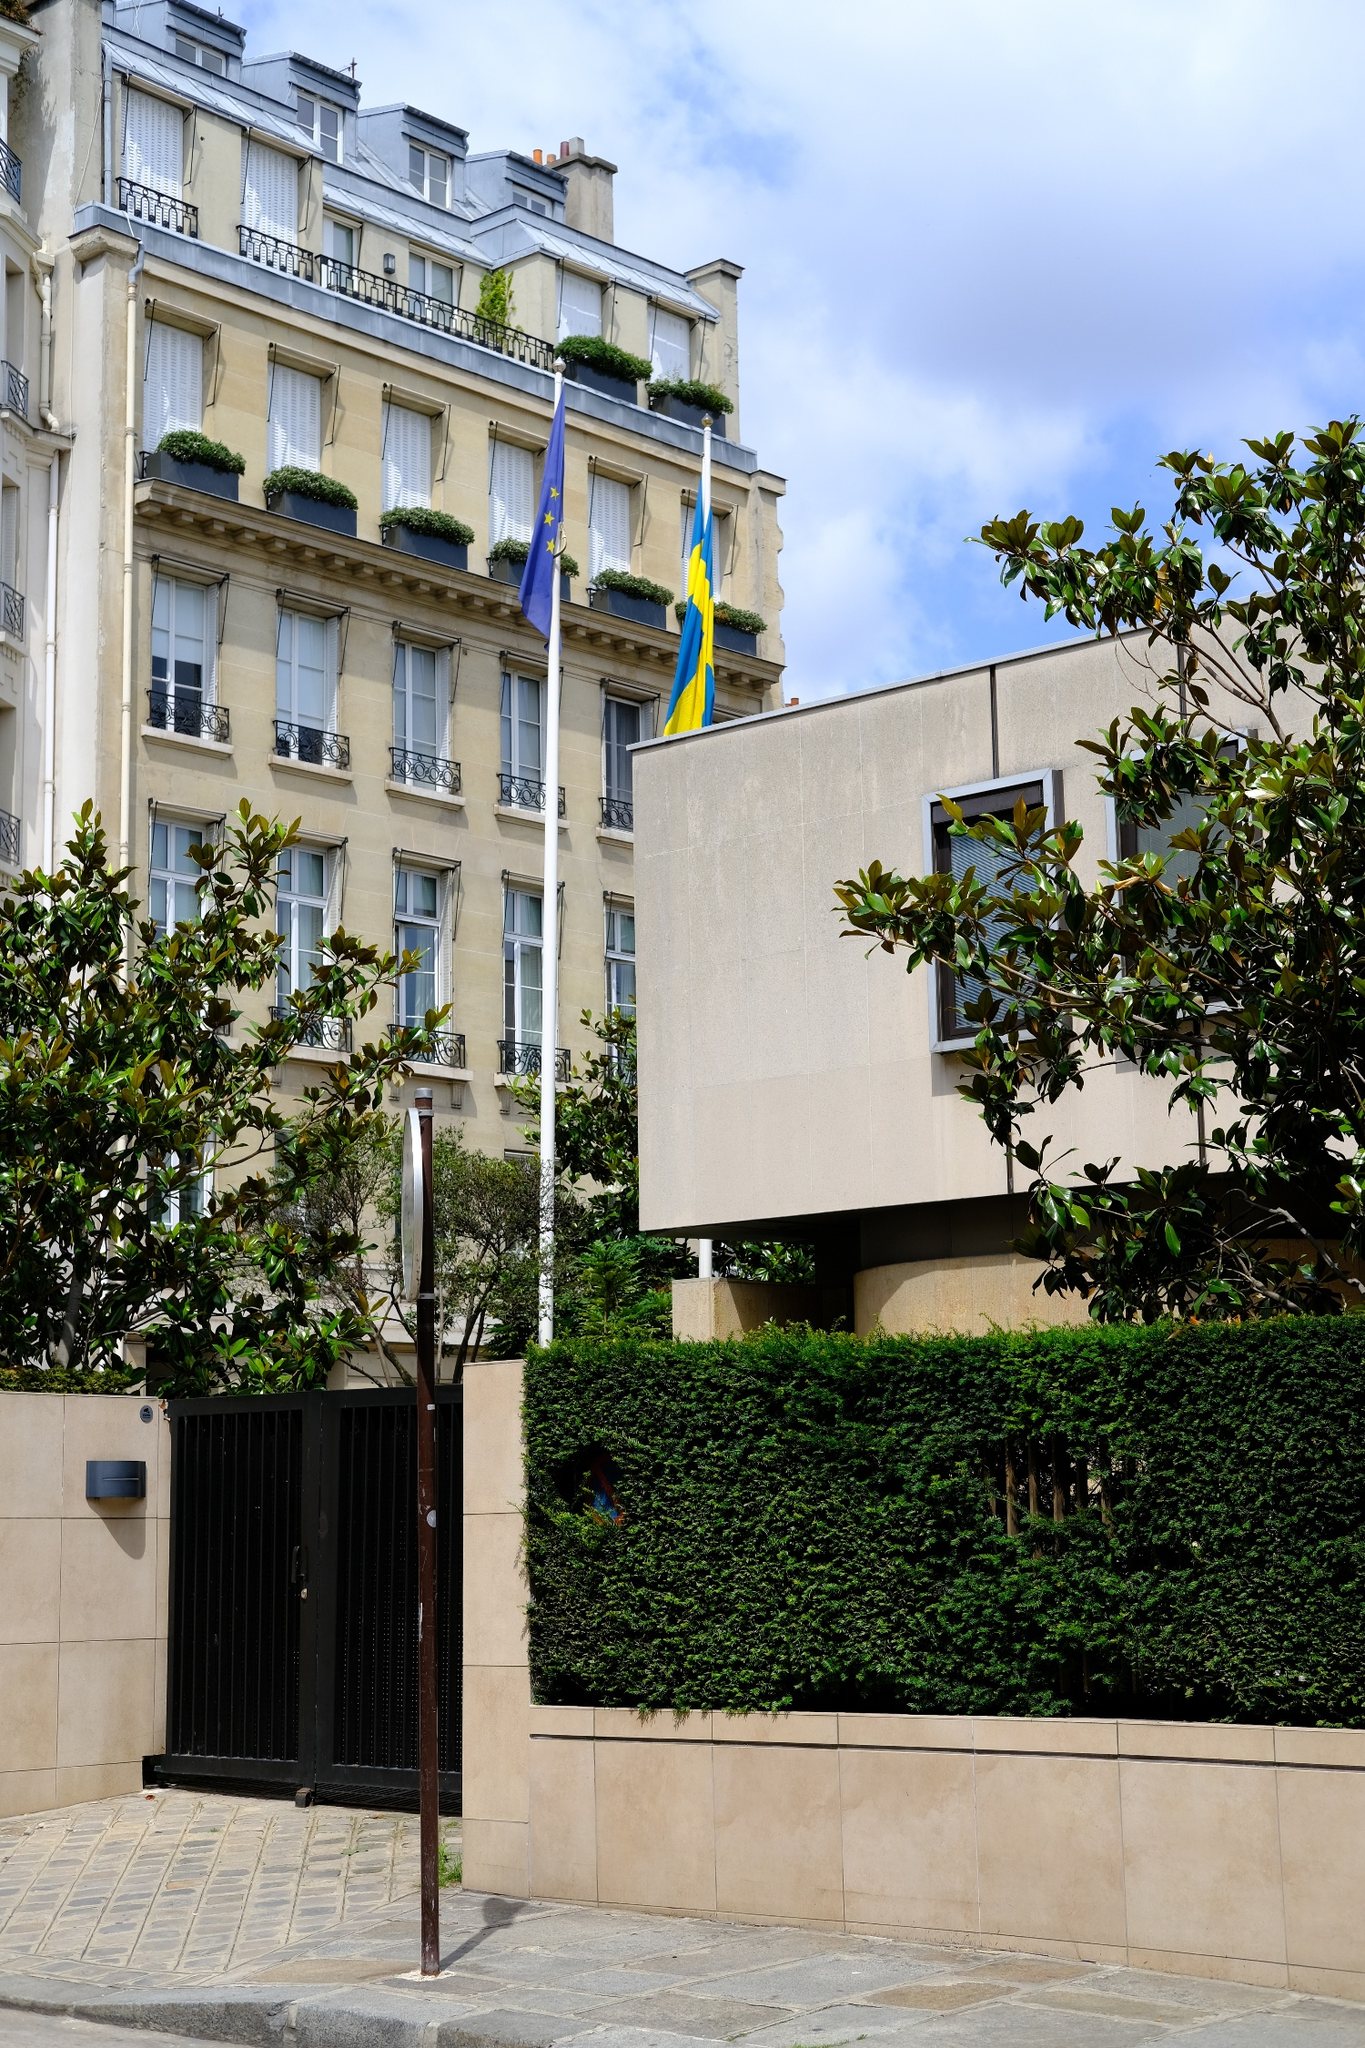If this building could speak, what stories might it tell us about its past? If this building could speak, it might regale us with tales of the elegant soirées and diplomatic events that have graced its halls over the decades. This might have been a sanctuary for great minds discussing progressive ideas, a front-row witness to the political and social transformations of Europe. It could tell stories of different generations of residents, their joys, and their trials, the laughter of children in its courtyards, and the quiet moments of reflection in its balconies. The architecture itself could speak of the artistry of the craftsmen who built it, each detail a labor of love and testament to a bygone era's dedication to beauty and function. 